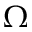Convert formula to latex. <formula><loc_0><loc_0><loc_500><loc_500>\Omega</formula> 